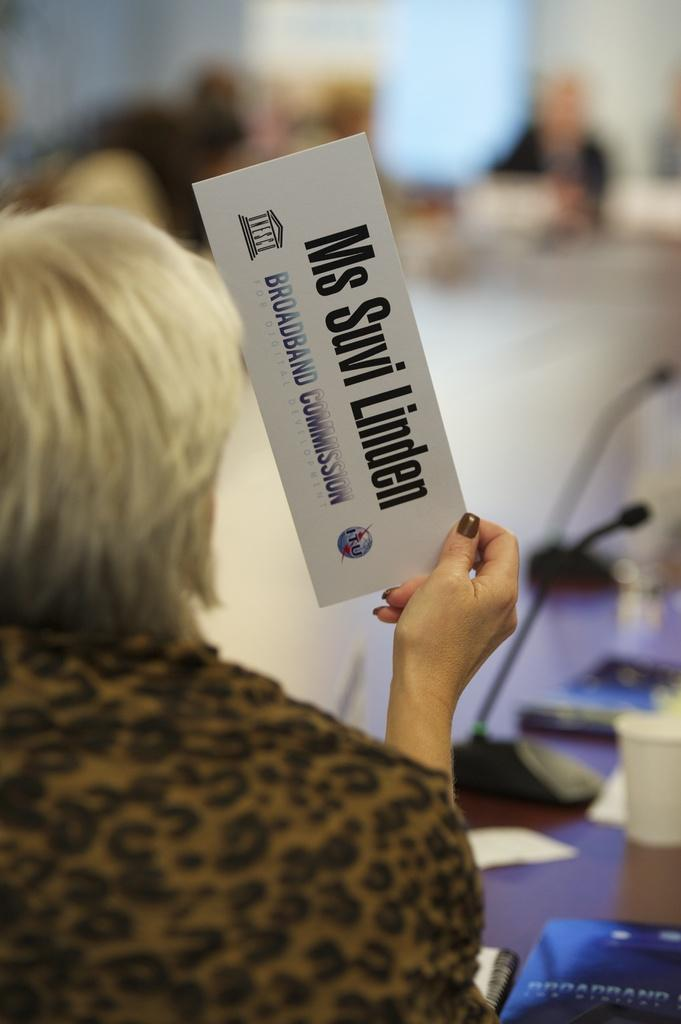What is the woman holding in the image? The woman is holding a text card in the image. What can be seen in the background of the image? The background of the image is blurred with people. What type of distance measurement can be seen in the image? Miles are visible in the image. What reading material is present in the image? There is a book and papers in the image. What object is on a table in the image? There is a cup on a table in the image. How many boys are touching the cup in the image? There are no boys present in the image, and the cup is not being touched by anyone. 